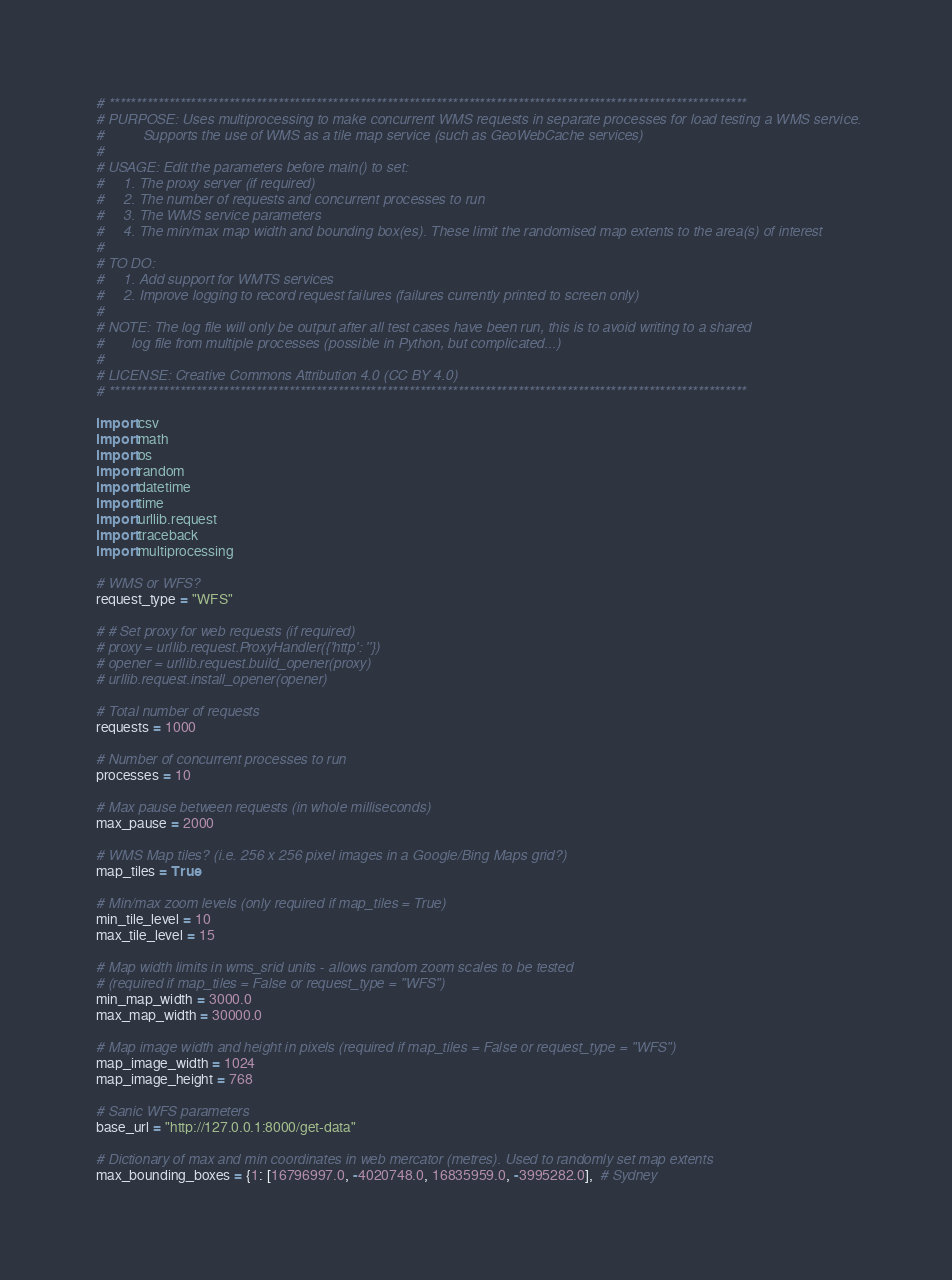<code> <loc_0><loc_0><loc_500><loc_500><_Python_># *********************************************************************************************************************
# PURPOSE: Uses multiprocessing to make concurrent WMS requests in separate processes for load testing a WMS service.
#          Supports the use of WMS as a tile map service (such as GeoWebCache services)
#
# USAGE: Edit the parameters before main() to set:
#     1. The proxy server (if required)
#     2. The number of requests and concurrent processes to run
#     3. The WMS service parameters
#     4. The min/max map width and bounding box(es). These limit the randomised map extents to the area(s) of interest
#
# TO DO:
#     1. Add support for WMTS services
#     2. Improve logging to record request failures (failures currently printed to screen only)
#
# NOTE: The log file will only be output after all test cases have been run, this is to avoid writing to a shared
#       log file from multiple processes (possible in Python, but complicated...)
#
# LICENSE: Creative Commons Attribution 4.0 (CC BY 4.0)
# *********************************************************************************************************************

import csv
import math
import os
import random
import datetime
import time
import urllib.request
import traceback
import multiprocessing

# WMS or WFS?
request_type = "WFS"

# # Set proxy for web requests (if required)
# proxy = urllib.request.ProxyHandler({'http': ''})
# opener = urllib.request.build_opener(proxy)
# urllib.request.install_opener(opener)

# Total number of requests
requests = 1000

# Number of concurrent processes to run
processes = 10

# Max pause between requests (in whole milliseconds)
max_pause = 2000

# WMS Map tiles? (i.e. 256 x 256 pixel images in a Google/Bing Maps grid?)
map_tiles = True

# Min/max zoom levels (only required if map_tiles = True)
min_tile_level = 10
max_tile_level = 15

# Map width limits in wms_srid units - allows random zoom scales to be tested
# (required if map_tiles = False or request_type = "WFS")
min_map_width = 3000.0
max_map_width = 30000.0

# Map image width and height in pixels (required if map_tiles = False or request_type = "WFS")
map_image_width = 1024
map_image_height = 768

# Sanic WFS parameters
base_url = "http://127.0.0.1:8000/get-data"

# Dictionary of max and min coordinates in web mercator (metres). Used to randomly set map extents
max_bounding_boxes = {1: [16796997.0, -4020748.0, 16835959.0, -3995282.0],  # Sydney</code> 